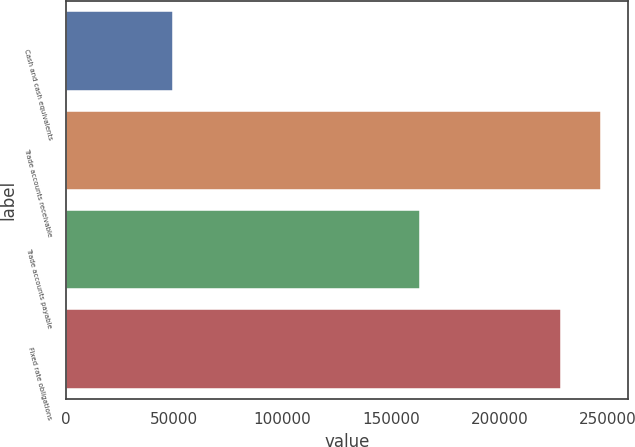<chart> <loc_0><loc_0><loc_500><loc_500><bar_chart><fcel>Cash and cash equivalents<fcel>Trade accounts receivable<fcel>Trade accounts payable<fcel>Fixed rate obligations<nl><fcel>49245<fcel>246731<fcel>163291<fcel>228331<nl></chart> 